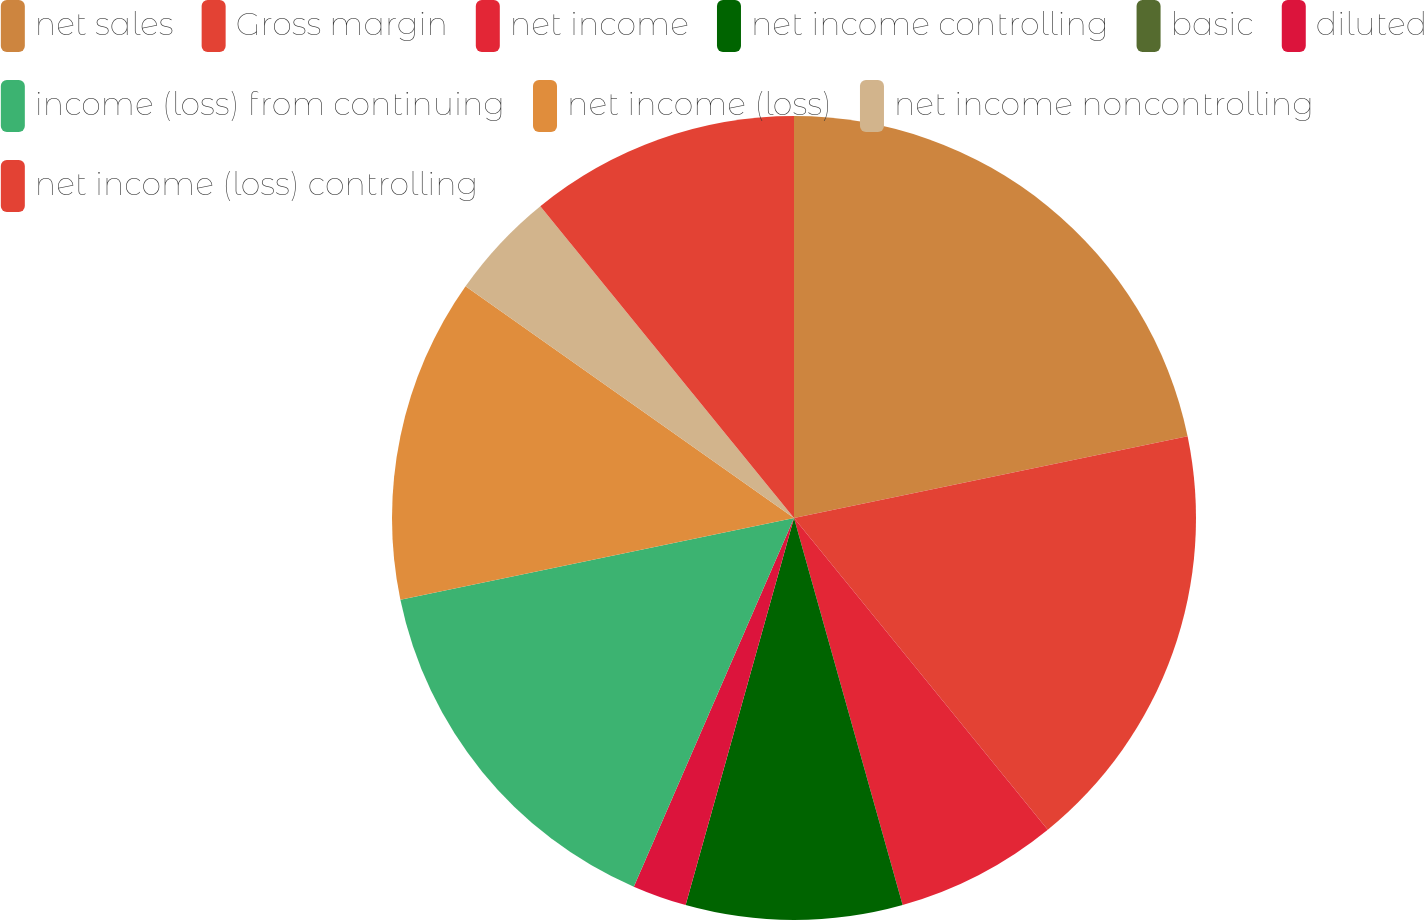Convert chart. <chart><loc_0><loc_0><loc_500><loc_500><pie_chart><fcel>net sales<fcel>Gross margin<fcel>net income<fcel>net income controlling<fcel>basic<fcel>diluted<fcel>income (loss) from continuing<fcel>net income (loss)<fcel>net income noncontrolling<fcel>net income (loss) controlling<nl><fcel>21.74%<fcel>17.39%<fcel>6.52%<fcel>8.7%<fcel>0.0%<fcel>2.18%<fcel>15.22%<fcel>13.04%<fcel>4.35%<fcel>10.87%<nl></chart> 